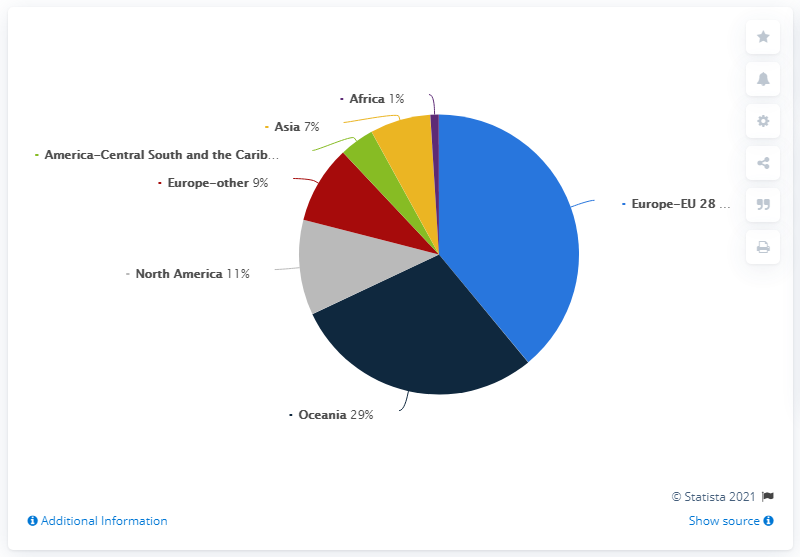Indicate a few pertinent items in this graphic. The pie chart shows 7 regions, which are represented on the chart. Approximately 38% of the world's population resides in Europe or Oceania. 